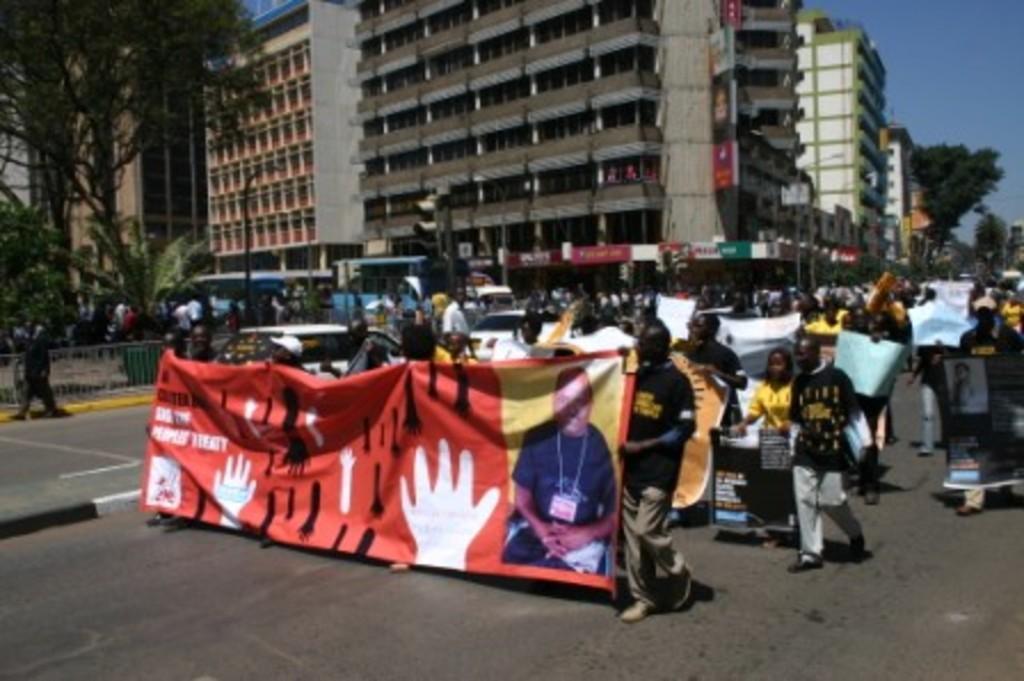Describe this image in one or two sentences. In this image there are people walking on the road by holding the banners. On the left side of the image there is a metal fence. There is a street light. There are traffic lights. In the background of the image there are buildings, trees and sky. 